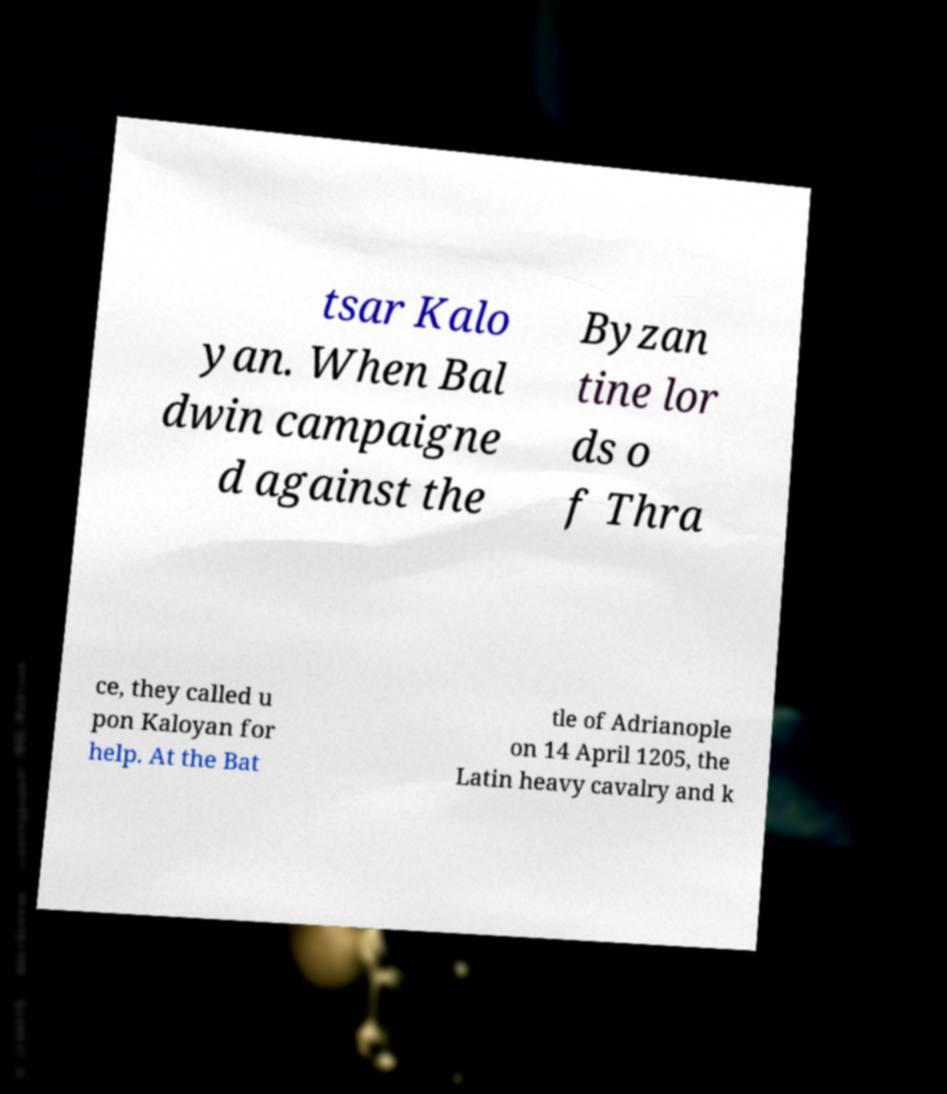Please identify and transcribe the text found in this image. tsar Kalo yan. When Bal dwin campaigne d against the Byzan tine lor ds o f Thra ce, they called u pon Kaloyan for help. At the Bat tle of Adrianople on 14 April 1205, the Latin heavy cavalry and k 